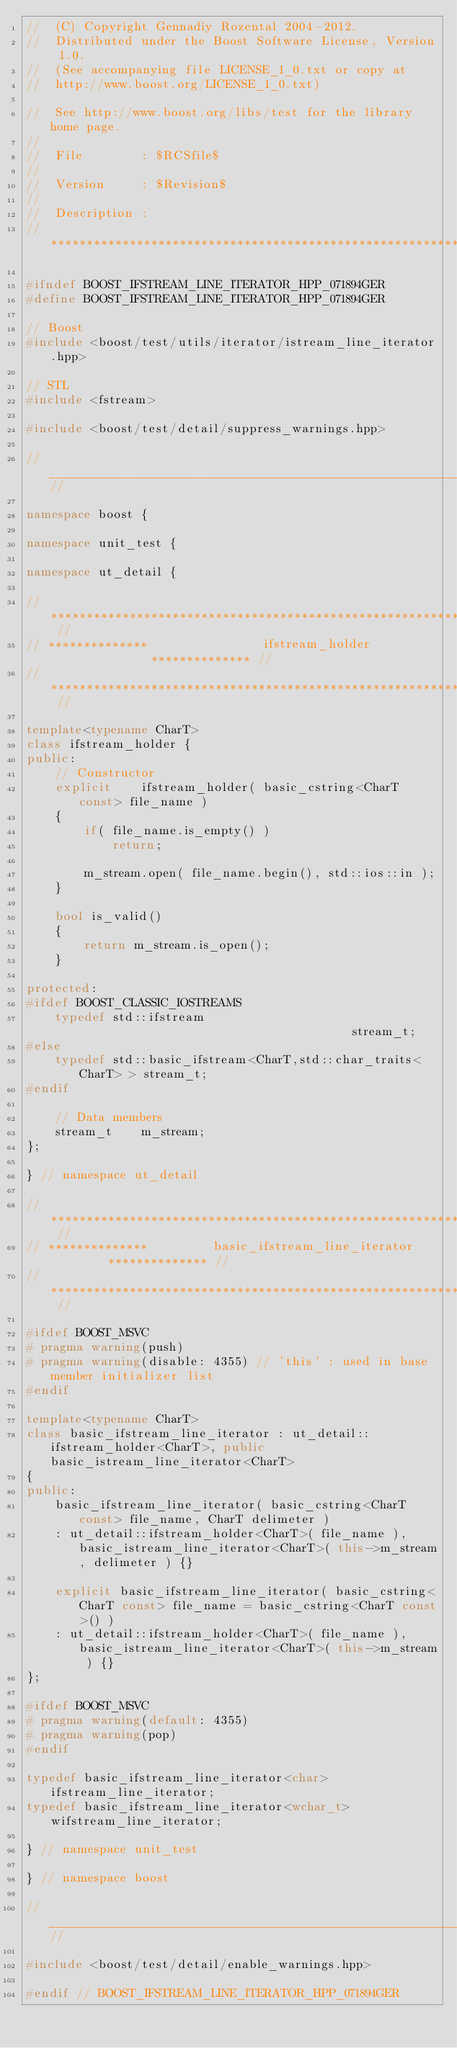Convert code to text. <code><loc_0><loc_0><loc_500><loc_500><_C++_>//  (C) Copyright Gennadiy Rozental 2004-2012.
//  Distributed under the Boost Software License, Version 1.0.
//  (See accompanying file LICENSE_1_0.txt or copy at 
//  http://www.boost.org/LICENSE_1_0.txt)

//  See http://www.boost.org/libs/test for the library home page.
//
//  File        : $RCSfile$
//
//  Version     : $Revision$
//
//  Description : 
// ***************************************************************************

#ifndef BOOST_IFSTREAM_LINE_ITERATOR_HPP_071894GER
#define BOOST_IFSTREAM_LINE_ITERATOR_HPP_071894GER

// Boost
#include <boost/test/utils/iterator/istream_line_iterator.hpp>

// STL
#include <fstream>

#include <boost/test/detail/suppress_warnings.hpp>

//____________________________________________________________________________//

namespace boost {

namespace unit_test {

namespace ut_detail {

// ************************************************************************** //
// **************                ifstream_holder               ************** //
// ************************************************************************** //

template<typename CharT>
class ifstream_holder {
public:
    // Constructor
    explicit    ifstream_holder( basic_cstring<CharT const> file_name )
    {
        if( file_name.is_empty() )
            return;

        m_stream.open( file_name.begin(), std::ios::in );
    }

    bool is_valid()
    {
        return m_stream.is_open();
    }

protected:
#ifdef BOOST_CLASSIC_IOSTREAMS
    typedef std::ifstream                                       stream_t;
#else
    typedef std::basic_ifstream<CharT,std::char_traits<CharT> > stream_t;
#endif

    // Data members
    stream_t    m_stream;
};

} // namespace ut_detail

// ************************************************************************** //
// **************         basic_ifstream_line_iterator         ************** //
// ************************************************************************** //

#ifdef BOOST_MSVC
# pragma warning(push)
# pragma warning(disable: 4355) // 'this' : used in base member initializer list
#endif

template<typename CharT>
class basic_ifstream_line_iterator : ut_detail::ifstream_holder<CharT>, public basic_istream_line_iterator<CharT>
{
public:
    basic_ifstream_line_iterator( basic_cstring<CharT const> file_name, CharT delimeter )
    : ut_detail::ifstream_holder<CharT>( file_name ), basic_istream_line_iterator<CharT>( this->m_stream, delimeter ) {}

    explicit basic_ifstream_line_iterator( basic_cstring<CharT const> file_name = basic_cstring<CharT const>() )
    : ut_detail::ifstream_holder<CharT>( file_name ), basic_istream_line_iterator<CharT>( this->m_stream ) {}
};

#ifdef BOOST_MSVC
# pragma warning(default: 4355)
# pragma warning(pop) 
#endif

typedef basic_ifstream_line_iterator<char>      ifstream_line_iterator;
typedef basic_ifstream_line_iterator<wchar_t>   wifstream_line_iterator;

} // namespace unit_test

} // namespace boost

//____________________________________________________________________________//

#include <boost/test/detail/enable_warnings.hpp>

#endif // BOOST_IFSTREAM_LINE_ITERATOR_HPP_071894GER

</code> 